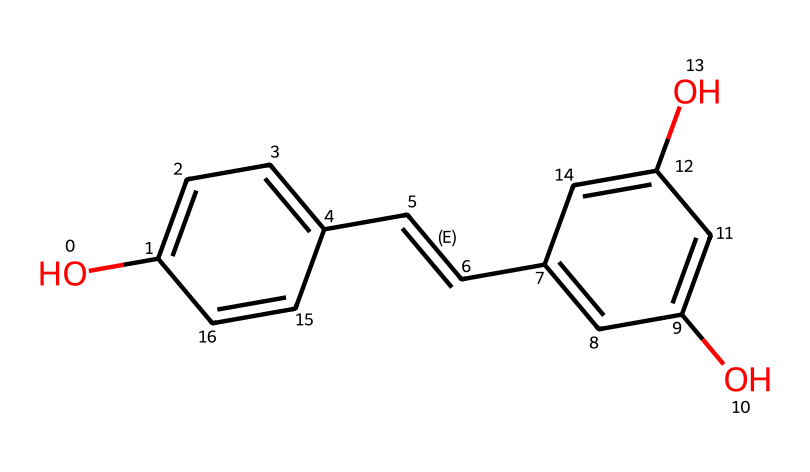What is the molecular formula of resveratrol? By analyzing the provided SMILES representation, we identify 14 carbon atoms (C), 12 hydrogen atoms (H), and 4 oxygen atoms (O), forming the molecular formula C14H12O4.
Answer: C14H12O4 How many hydroxyl (–OH) groups are present in resveratrol? From the visual depiction and interpretation of the SMILES, we see two clear hydroxyl (–OH) groups attached to the benzene rings.
Answer: 2 What type of bonding is primarily exhibited in the resveratrol structure? Resveratrol contains a combination of single and double bonds, specifically a double bond between carbon atoms (C=C). The primary type of bonding here is covalent bonding within the organic molecular framework.
Answer: covalent How many aromatic rings are present in resveratrol? The chemical structure reveals two distinct benzene (aromatic) rings, indicating the presence of two aromatic structures.
Answer: 2 What is the significance of the double bond in resveratrol? The double bond (C=C) in resveratrol allows for conjugation with the adjacent aromatic ring systems, which enhances its antioxidant properties by stabilizing free radicals.
Answer: antioxidant properties What role do the hydroxyl groups play in the antioxidant capacity of resveratrol? The hydroxyl groups facilitate electron donation, allowing resveratrol to neutralize free radicals effectively, thus enhancing its ability to act as an antioxidant.
Answer: electron donation 